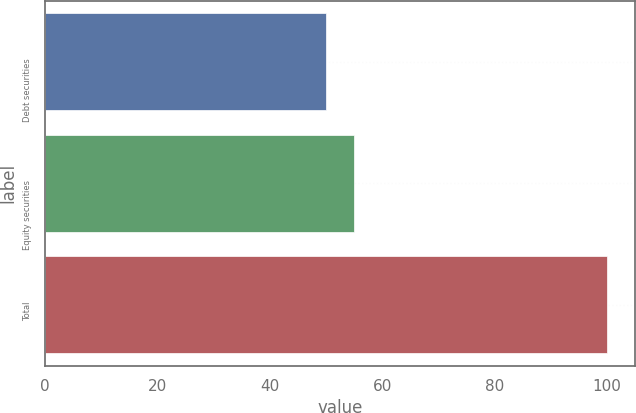Convert chart to OTSL. <chart><loc_0><loc_0><loc_500><loc_500><bar_chart><fcel>Debt securities<fcel>Equity securities<fcel>Total<nl><fcel>50<fcel>55<fcel>100<nl></chart> 